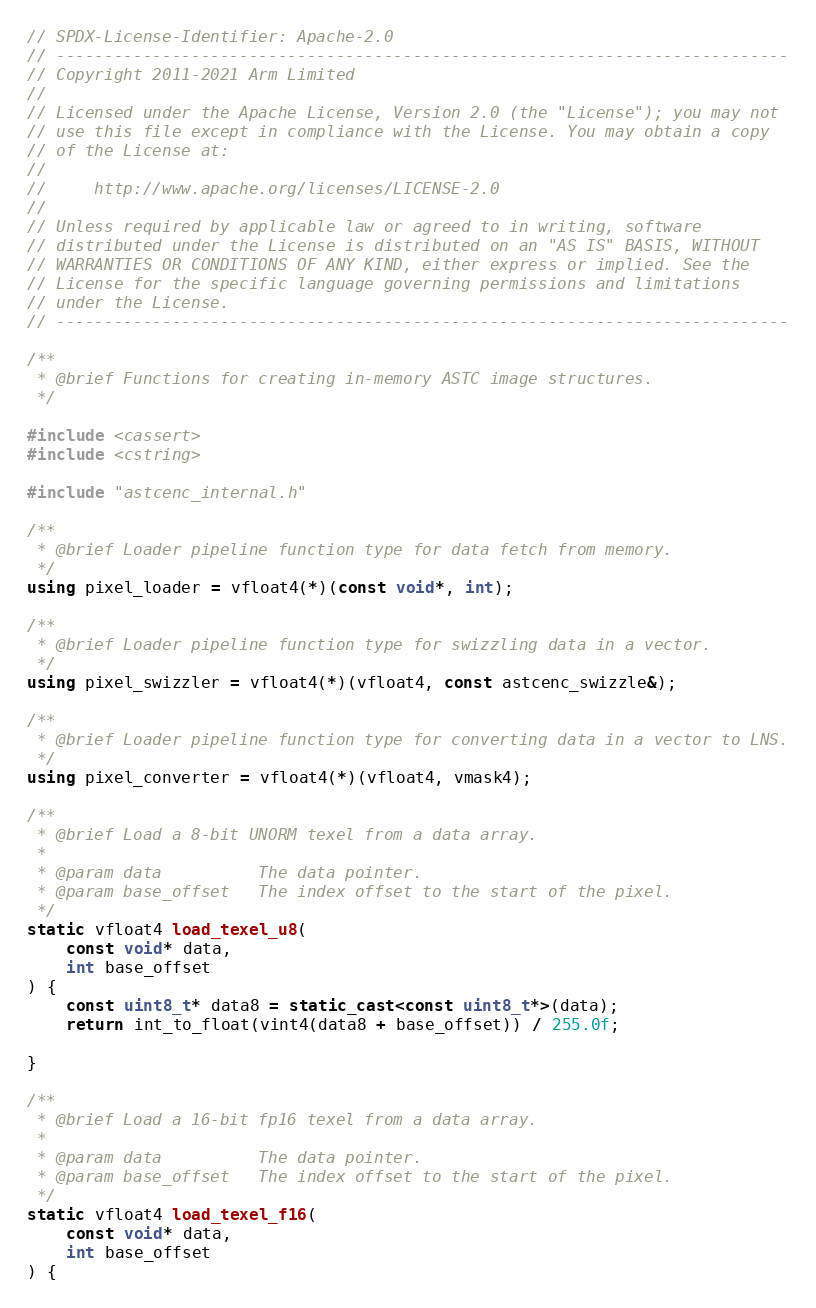Convert code to text. <code><loc_0><loc_0><loc_500><loc_500><_C++_>// SPDX-License-Identifier: Apache-2.0
// ----------------------------------------------------------------------------
// Copyright 2011-2021 Arm Limited
//
// Licensed under the Apache License, Version 2.0 (the "License"); you may not
// use this file except in compliance with the License. You may obtain a copy
// of the License at:
//
//     http://www.apache.org/licenses/LICENSE-2.0
//
// Unless required by applicable law or agreed to in writing, software
// distributed under the License is distributed on an "AS IS" BASIS, WITHOUT
// WARRANTIES OR CONDITIONS OF ANY KIND, either express or implied. See the
// License for the specific language governing permissions and limitations
// under the License.
// ----------------------------------------------------------------------------

/**
 * @brief Functions for creating in-memory ASTC image structures.
 */

#include <cassert>
#include <cstring>

#include "astcenc_internal.h"

/**
 * @brief Loader pipeline function type for data fetch from memory.
 */
using pixel_loader = vfloat4(*)(const void*, int);

/**
 * @brief Loader pipeline function type for swizzling data in a vector.
 */
using pixel_swizzler = vfloat4(*)(vfloat4, const astcenc_swizzle&);

/**
 * @brief Loader pipeline function type for converting data in a vector to LNS.
 */
using pixel_converter = vfloat4(*)(vfloat4, vmask4);

/**
 * @brief Load a 8-bit UNORM texel from a data array.
 *
 * @param data          The data pointer.
 * @param base_offset   The index offset to the start of the pixel.
 */
static vfloat4 load_texel_u8(
	const void* data,
	int base_offset
) {
	const uint8_t* data8 = static_cast<const uint8_t*>(data);
	return int_to_float(vint4(data8 + base_offset)) / 255.0f;

}

/**
 * @brief Load a 16-bit fp16 texel from a data array.
 *
 * @param data          The data pointer.
 * @param base_offset   The index offset to the start of the pixel.
 */
static vfloat4 load_texel_f16(
	const void* data,
	int base_offset
) {</code> 